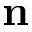Convert formula to latex. <formula><loc_0><loc_0><loc_500><loc_500>n</formula> 